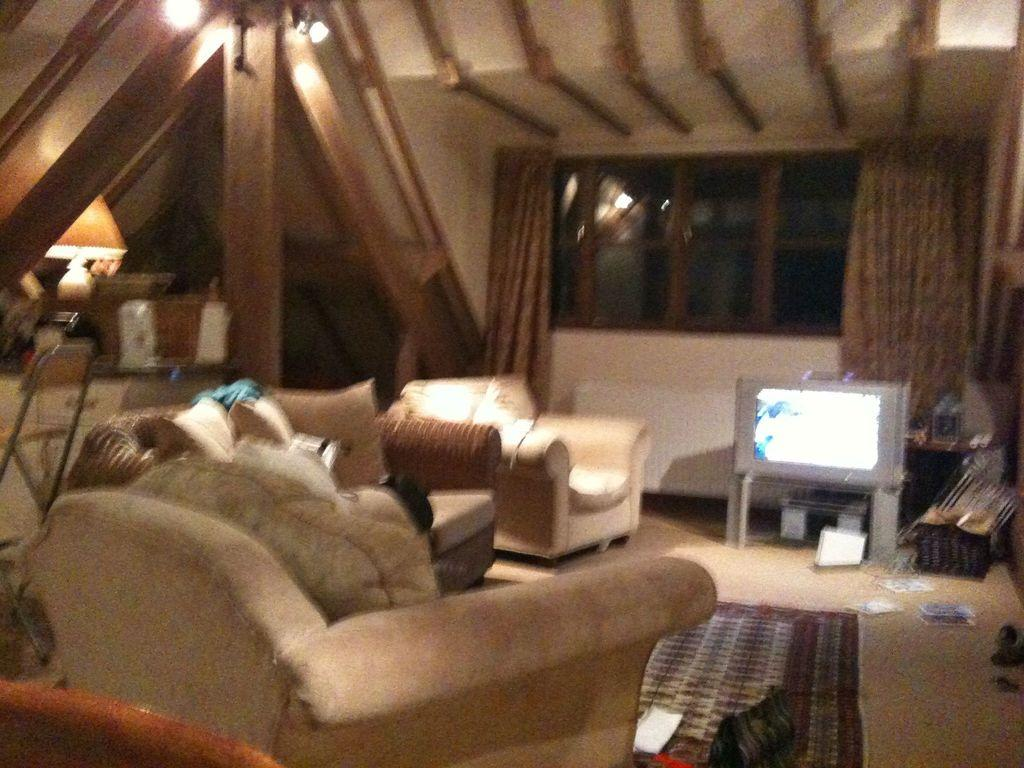What type of space is depicted in the image? There is a room in the image. What furniture is present in the room? There is a sofa, a door mat, a television, and a desk in the room. What might be used for seating in the room? The sofa can be used for seating in the room. What is placed on the desk in the room? There are things placed on the desk in the room. How many giants are visible in the room in the image? There are no giants present in the image; it depicts a room with furniture and objects. What type of truck can be seen parked in front of the room in the image? There is no truck visible in the image; it only shows a room with furniture and objects. 